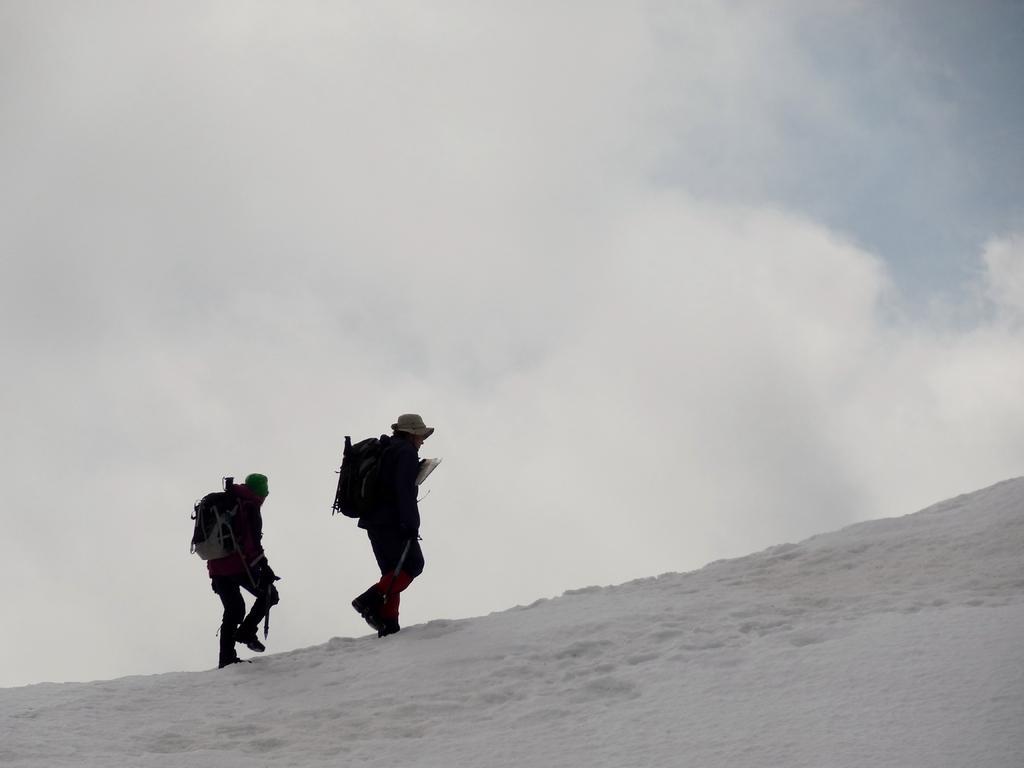Can you describe this image briefly? This is an outside view. On the left side there are two persons wearing bags, caps on the heads and walking on the snow. At the top of the image I can see the sky and clouds. 